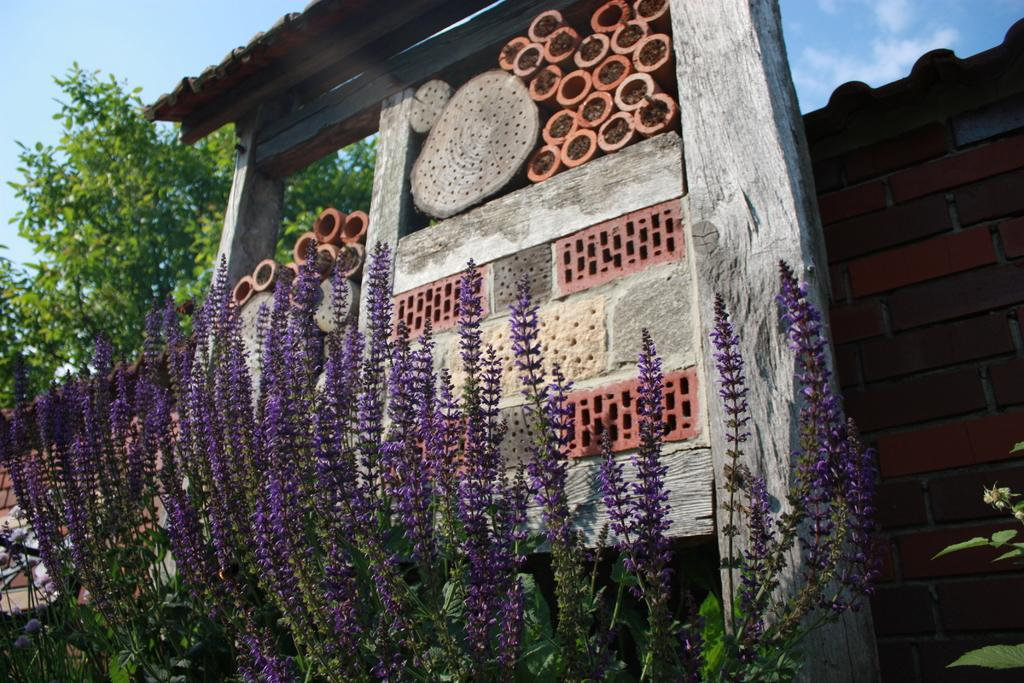What type of vegetation can be seen in the image? There are plants and trees in the image. What is visible in the background of the image? There is a brick wall and the sky visible in the background of the image. Can you describe any other elements in the background of the image? There are other unspecified elements in the background of the image. What type of chin can be seen on the tree in the image? There is no chin present in the image, as it features plants, trees, and a brick wall in the background. What is the pen used for in the image? There is no pen present in the image. 